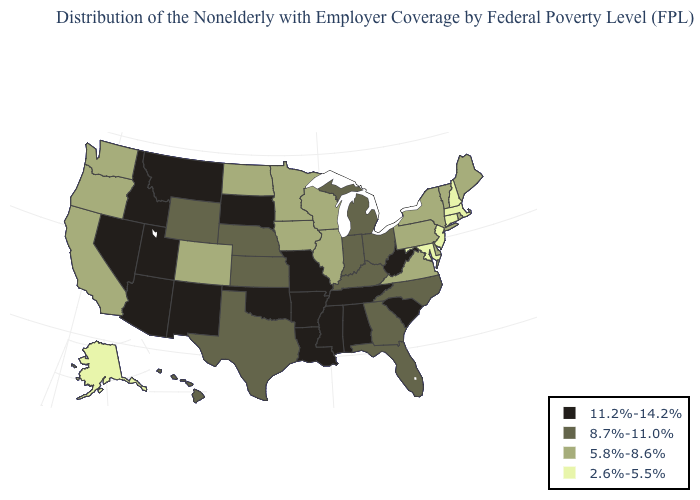Does Pennsylvania have a higher value than Florida?
Quick response, please. No. What is the value of Colorado?
Answer briefly. 5.8%-8.6%. Name the states that have a value in the range 8.7%-11.0%?
Concise answer only. Florida, Georgia, Hawaii, Indiana, Kansas, Kentucky, Michigan, Nebraska, North Carolina, Ohio, Texas, Wyoming. What is the value of Missouri?
Be succinct. 11.2%-14.2%. Which states have the lowest value in the Northeast?
Write a very short answer. Connecticut, Massachusetts, New Hampshire, New Jersey. Does New York have a lower value than Maryland?
Be succinct. No. Does Ohio have the same value as California?
Write a very short answer. No. Among the states that border Minnesota , does Iowa have the highest value?
Be succinct. No. What is the highest value in states that border Vermont?
Be succinct. 5.8%-8.6%. Name the states that have a value in the range 2.6%-5.5%?
Give a very brief answer. Alaska, Connecticut, Maryland, Massachusetts, New Hampshire, New Jersey. Name the states that have a value in the range 5.8%-8.6%?
Write a very short answer. California, Colorado, Delaware, Illinois, Iowa, Maine, Minnesota, New York, North Dakota, Oregon, Pennsylvania, Rhode Island, Vermont, Virginia, Washington, Wisconsin. Name the states that have a value in the range 8.7%-11.0%?
Short answer required. Florida, Georgia, Hawaii, Indiana, Kansas, Kentucky, Michigan, Nebraska, North Carolina, Ohio, Texas, Wyoming. Among the states that border Nevada , does Oregon have the highest value?
Concise answer only. No. What is the lowest value in the USA?
Keep it brief. 2.6%-5.5%. Name the states that have a value in the range 11.2%-14.2%?
Be succinct. Alabama, Arizona, Arkansas, Idaho, Louisiana, Mississippi, Missouri, Montana, Nevada, New Mexico, Oklahoma, South Carolina, South Dakota, Tennessee, Utah, West Virginia. 